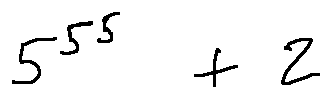Convert formula to latex. <formula><loc_0><loc_0><loc_500><loc_500>5 ^ { 5 ^ { 5 } } + 2</formula> 